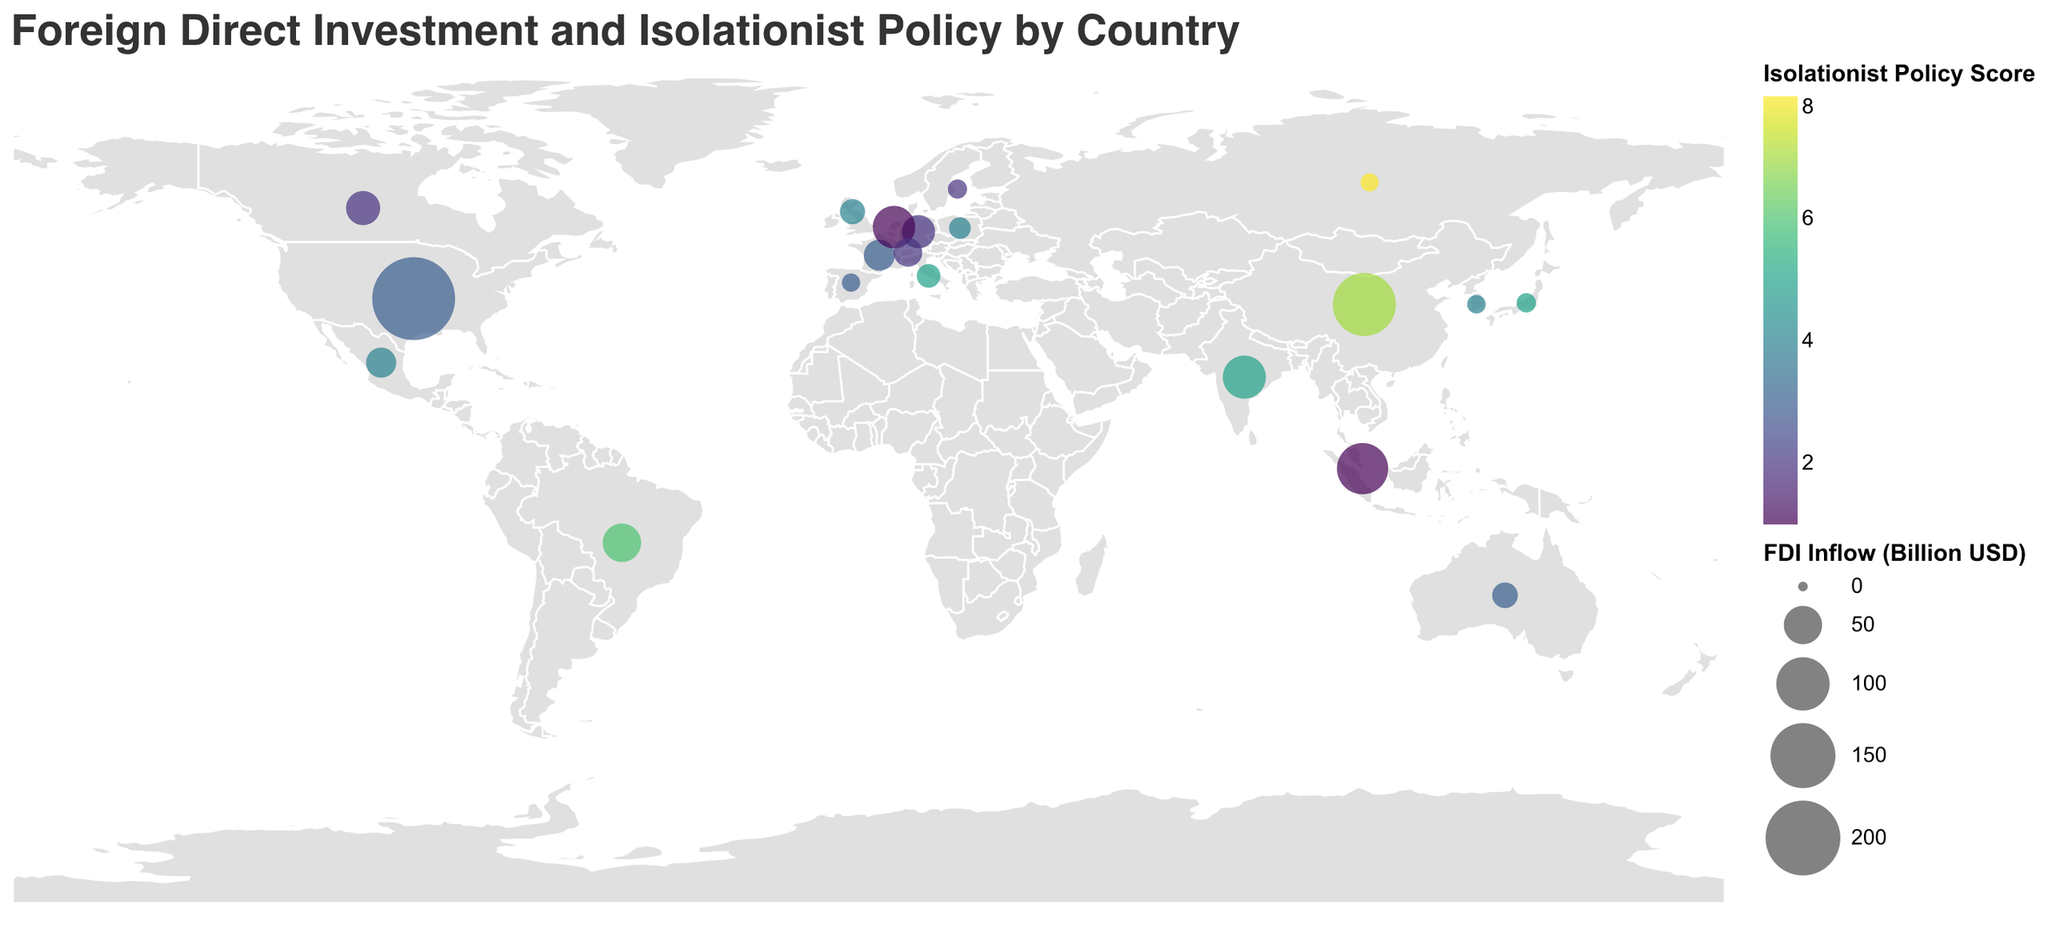What's the title of the plot? The title is placed at the top of the plot in a larger font size to make it easily readable. It indicates the overall subject of the data visualization.
Answer: Foreign Direct Investment and Isolationist Policy by Country Which country has the highest FDI inflow? By examining the size of the circles on the map, the United States has the largest circle, indicating the highest level of FDI inflow among the countries.
Answer: United States How is the Isolationist Policy Score represented in the plot? The Isolationist Policy Score is represented by the color of the circles. A color scale is used, probably ranging from lighter to darker shades indicating lower to higher scores.
Answer: By color What is the relationship between FDI inflow and isolationist policy for China compared to Brazil? To compare, look at the position, size, and color of the circles for China and Brazil. China's circle is larger and darker, indicating higher FDI but also a higher isolationist score compared to Brazil.
Answer: China has higher FDI inflow and higher isolationist policy score than Brazil Which country with a low Isolationist Policy Score has significant FDI inflow? By looking at the color and size relationship, the Netherlands and Singapore have very low isolationist scores (color) and still have significant FDI inflows (large circles).
Answer: Netherlands and Singapore What's the average FDI inflow for countries with an Isolationist Policy Score greater than 5? To get this, add the FDI inflows of countries with isolationist scores greater than 5 (China, Brazil, Russia) and divide by the number of countries. \( (141.2 + 50.4 + 8.6) / 3 = 66.73 \).
Answer: 66.73 billion USD How does FDI inflow for countries in Europe appear in terms of Isolationist Policy? Examining European countries (Germany, United Kingdom, France, Italy, Spain, Netherlands, Switzerland, Sweden, Poland) and their color and size can provide insight. Most European countries have moderate Isolationist Policy scores and varying FDI inflow sizes.
Answer: Moderate Isolationist Policy scores and variable FDI inflows What can you infer about the relationship between FDI inflow and Isolationist Policy Score from this plot? The plot generally suggests an inverse relationship where countries with higher isolationist scores tend to have lower FDI inflows, visible by smaller circles associated with darker colors. However, there are exceptions like China.
Answer: Inverse relationship generally, with exceptions 